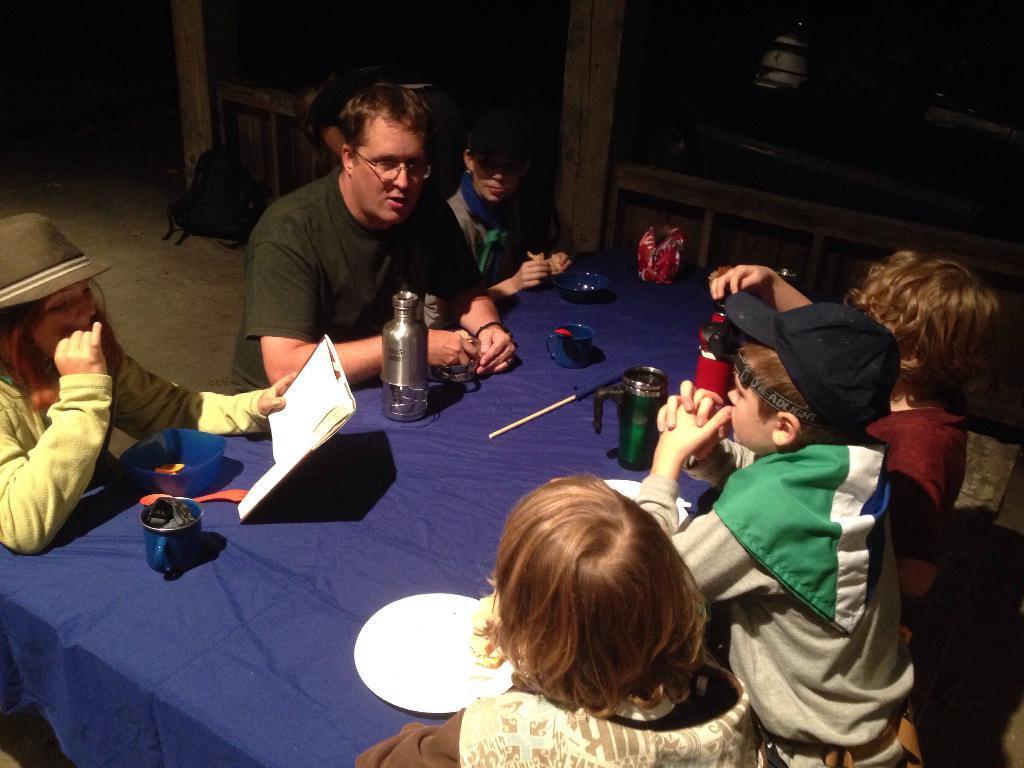How would you summarize this image in a sentence or two? A man is sitting with a group of children. There are some flask,boxes,cups and plates on the table. There is a blue color cloth on the table. 